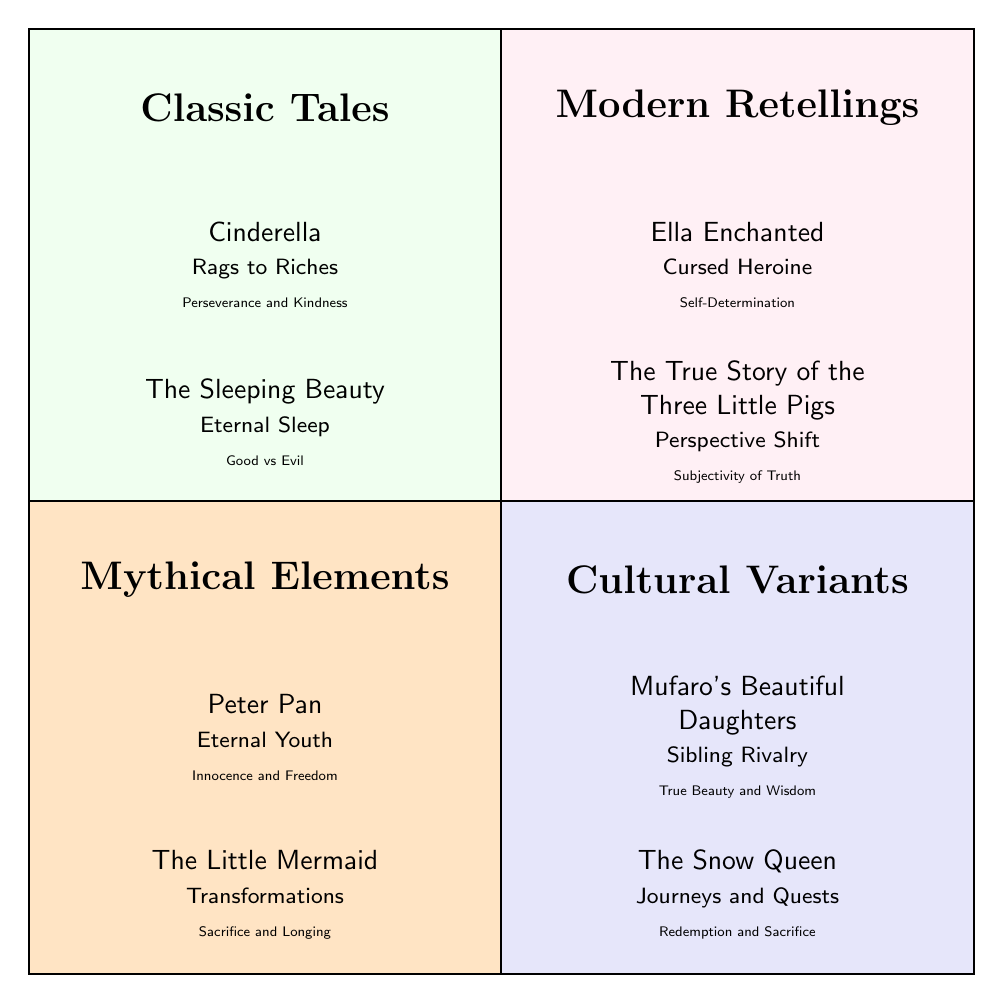What are the two examples in the Classic Tales quadrant? The Classic Tales quadrant features "Cinderella" and "The Sleeping Beauty" as examples based on the information presented.
Answer: Cinderella, The Sleeping Beauty What motif is associated with "Ella Enchanted"? "Ella Enchanted" is associated with the motif "Cursed Heroine" as indicated in the Modern Retellings quadrant.
Answer: Cursed Heroine How many examples are listed in the Cultural Variants quadrant? There are two examples provided in the Cultural Variants quadrant; they are "Mufaro’s Beautiful Daughters" and "The Snow Queen."
Answer: 2 Which theme is linked to "Peter Pan"? "Peter Pan" is linked to the theme "Innocence and Freedom," which is specified in the Mythical Elements quadrant.
Answer: Innocence and Freedom What is a common motif found in both the Classic Tales and Cultural Variants quadrants? The Classic Tales quadrant has motifs related to traditional fairy tale elements, while the Cultural Variants quadrant also features motifs, but there are no direct matches listed in the data provided. Thus, there is none.
Answer: None Which quadrant features tales that embody self-determination? The quadrant featuring tales that embody self-determination is Modern Retellings, specifically through "Ella Enchanted" as its example.
Answer: Modern Retellings What is the theme associated with "The Snow Queen"? The theme associated with "The Snow Queen" is "Redemption and Sacrifice," as stated in the Cultural Variants quadrant.
Answer: Redemption and Sacrifice In which quadrant would you find the motif "Transformations"? The motif "Transformations" is found in the Mythical Elements quadrant, associated with "The Little Mermaid."
Answer: Mythical Elements How many quadrants are represented in the diagram? There are four quadrants represented in the diagram, which include Classic Tales, Modern Retellings, Mythical Elements, and Cultural Variants.
Answer: 4 